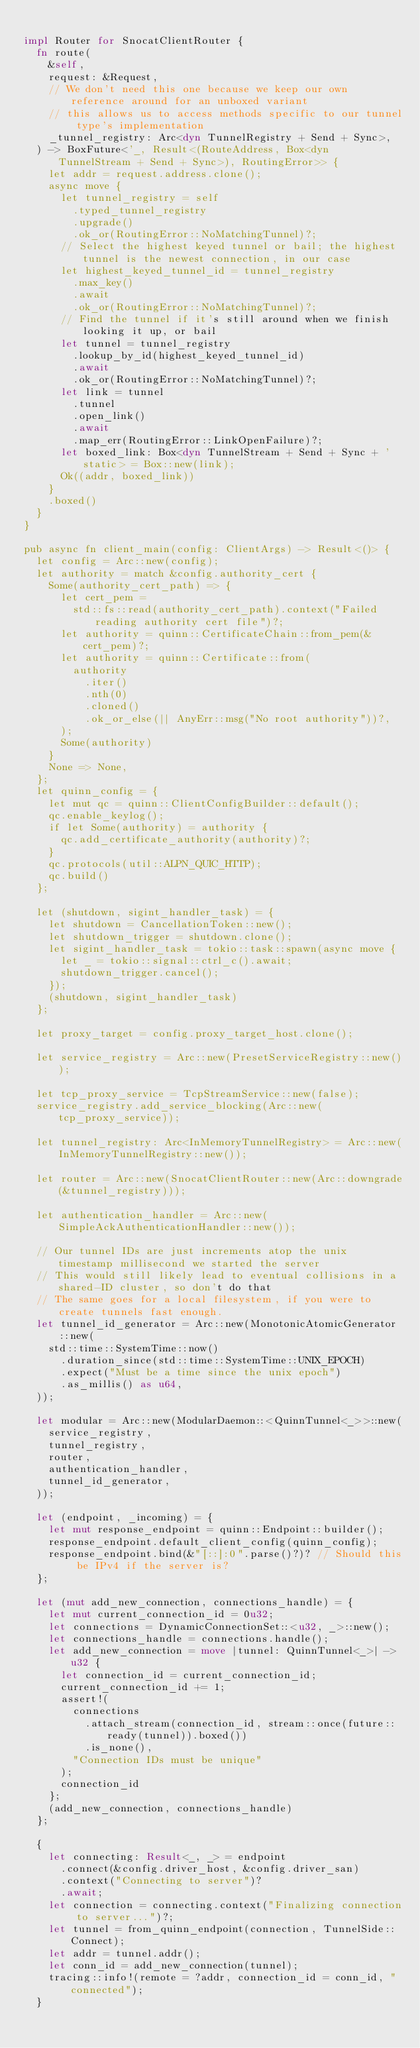Convert code to text. <code><loc_0><loc_0><loc_500><loc_500><_Rust_>
impl Router for SnocatClientRouter {
  fn route(
    &self,
    request: &Request,
    // We don't need this one because we keep our own reference around for an unboxed variant
    // this allows us to access methods specific to our tunnel type's implementation
    _tunnel_registry: Arc<dyn TunnelRegistry + Send + Sync>,
  ) -> BoxFuture<'_, Result<(RouteAddress, Box<dyn TunnelStream + Send + Sync>), RoutingError>> {
    let addr = request.address.clone();
    async move {
      let tunnel_registry = self
        .typed_tunnel_registry
        .upgrade()
        .ok_or(RoutingError::NoMatchingTunnel)?;
      // Select the highest keyed tunnel or bail; the highest tunnel is the newest connection, in our case
      let highest_keyed_tunnel_id = tunnel_registry
        .max_key()
        .await
        .ok_or(RoutingError::NoMatchingTunnel)?;
      // Find the tunnel if it's still around when we finish looking it up, or bail
      let tunnel = tunnel_registry
        .lookup_by_id(highest_keyed_tunnel_id)
        .await
        .ok_or(RoutingError::NoMatchingTunnel)?;
      let link = tunnel
        .tunnel
        .open_link()
        .await
        .map_err(RoutingError::LinkOpenFailure)?;
      let boxed_link: Box<dyn TunnelStream + Send + Sync + 'static> = Box::new(link);
      Ok((addr, boxed_link))
    }
    .boxed()
  }
}

pub async fn client_main(config: ClientArgs) -> Result<()> {
  let config = Arc::new(config);
  let authority = match &config.authority_cert {
    Some(authority_cert_path) => {
      let cert_pem =
        std::fs::read(authority_cert_path).context("Failed reading authority cert file")?;
      let authority = quinn::CertificateChain::from_pem(&cert_pem)?;
      let authority = quinn::Certificate::from(
        authority
          .iter()
          .nth(0)
          .cloned()
          .ok_or_else(|| AnyErr::msg("No root authority"))?,
      );
      Some(authority)
    }
    None => None,
  };
  let quinn_config = {
    let mut qc = quinn::ClientConfigBuilder::default();
    qc.enable_keylog();
    if let Some(authority) = authority {
      qc.add_certificate_authority(authority)?;
    }
    qc.protocols(util::ALPN_QUIC_HTTP);
    qc.build()
  };

  let (shutdown, sigint_handler_task) = {
    let shutdown = CancellationToken::new();
    let shutdown_trigger = shutdown.clone();
    let sigint_handler_task = tokio::task::spawn(async move {
      let _ = tokio::signal::ctrl_c().await;
      shutdown_trigger.cancel();
    });
    (shutdown, sigint_handler_task)
  };

  let proxy_target = config.proxy_target_host.clone();

  let service_registry = Arc::new(PresetServiceRegistry::new());

  let tcp_proxy_service = TcpStreamService::new(false);
  service_registry.add_service_blocking(Arc::new(tcp_proxy_service));

  let tunnel_registry: Arc<InMemoryTunnelRegistry> = Arc::new(InMemoryTunnelRegistry::new());

  let router = Arc::new(SnocatClientRouter::new(Arc::downgrade(&tunnel_registry)));

  let authentication_handler = Arc::new(SimpleAckAuthenticationHandler::new());

  // Our tunnel IDs are just increments atop the unix timestamp millisecond we started the server
  // This would still likely lead to eventual collisions in a shared-ID cluster, so don't do that
  // The same goes for a local filesystem, if you were to create tunnels fast enough.
  let tunnel_id_generator = Arc::new(MonotonicAtomicGenerator::new(
    std::time::SystemTime::now()
      .duration_since(std::time::SystemTime::UNIX_EPOCH)
      .expect("Must be a time since the unix epoch")
      .as_millis() as u64,
  ));

  let modular = Arc::new(ModularDaemon::<QuinnTunnel<_>>::new(
    service_registry,
    tunnel_registry,
    router,
    authentication_handler,
    tunnel_id_generator,
  ));

  let (endpoint, _incoming) = {
    let mut response_endpoint = quinn::Endpoint::builder();
    response_endpoint.default_client_config(quinn_config);
    response_endpoint.bind(&"[::]:0".parse()?)? // Should this be IPv4 if the server is?
  };

  let (mut add_new_connection, connections_handle) = {
    let mut current_connection_id = 0u32;
    let connections = DynamicConnectionSet::<u32, _>::new();
    let connections_handle = connections.handle();
    let add_new_connection = move |tunnel: QuinnTunnel<_>| -> u32 {
      let connection_id = current_connection_id;
      current_connection_id += 1;
      assert!(
        connections
          .attach_stream(connection_id, stream::once(future::ready(tunnel)).boxed())
          .is_none(),
        "Connection IDs must be unique"
      );
      connection_id
    };
    (add_new_connection, connections_handle)
  };

  {
    let connecting: Result<_, _> = endpoint
      .connect(&config.driver_host, &config.driver_san)
      .context("Connecting to server")?
      .await;
    let connection = connecting.context("Finalizing connection to server...")?;
    let tunnel = from_quinn_endpoint(connection, TunnelSide::Connect);
    let addr = tunnel.addr();
    let conn_id = add_new_connection(tunnel);
    tracing::info!(remote = ?addr, connection_id = conn_id, "connected");
  }
</code> 